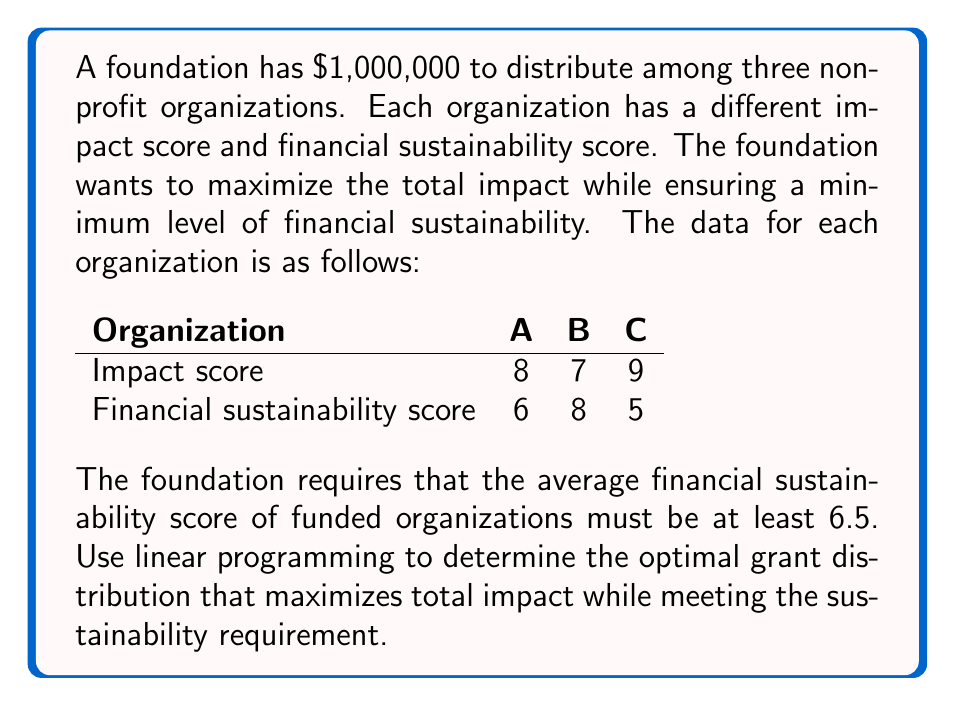Show me your answer to this math problem. Let's solve this step-by-step using linear programming:

1. Define variables:
   Let $x_A$, $x_B$, and $x_C$ be the amounts granted to organizations A, B, and C respectively.

2. Objective function:
   Maximize total impact = $8x_A + 7x_B + 9x_C$

3. Constraints:
   a) Total budget: $x_A + x_B + x_C \leq 1,000,000$
   b) Non-negativity: $x_A, x_B, x_C \geq 0$
   c) Financial sustainability: $\frac{6x_A + 8x_B + 5x_C}{x_A + x_B + x_C} \geq 6.5$

4. Simplify the sustainability constraint:
   $6x_A + 8x_B + 5x_C \geq 6.5(x_A + x_B + x_C)$
   $6x_A + 8x_B + 5x_C \geq 6.5x_A + 6.5x_B + 6.5x_C$
   $-0.5x_A + 1.5x_B - 1.5x_C \geq 0$

5. Solve using the simplex method or linear programming software:
   The optimal solution is:
   $x_A = 0$
   $x_B = 750,000$
   $x_C = 250,000$

6. Verify the solution:
   a) Total budget: $0 + 750,000 + 250,000 = 1,000,000$ (satisfied)
   b) Non-negativity: All values are non-negative (satisfied)
   c) Financial sustainability: 
      $\frac{6(0) + 8(750,000) + 5(250,000)}{0 + 750,000 + 250,000} = 7.25 \geq 6.5$ (satisfied)

7. Calculate total impact:
   Total impact = $8(0) + 7(750,000) + 9(250,000) = 7,500,000$

Therefore, the optimal grant distribution is $750,000 to Organization B and $250,000 to Organization C, resulting in a total impact score of 7,500,000 while meeting the financial sustainability requirement.
Answer: Organization B: $750,000; Organization C: $250,000; Total impact: 7,500,000 